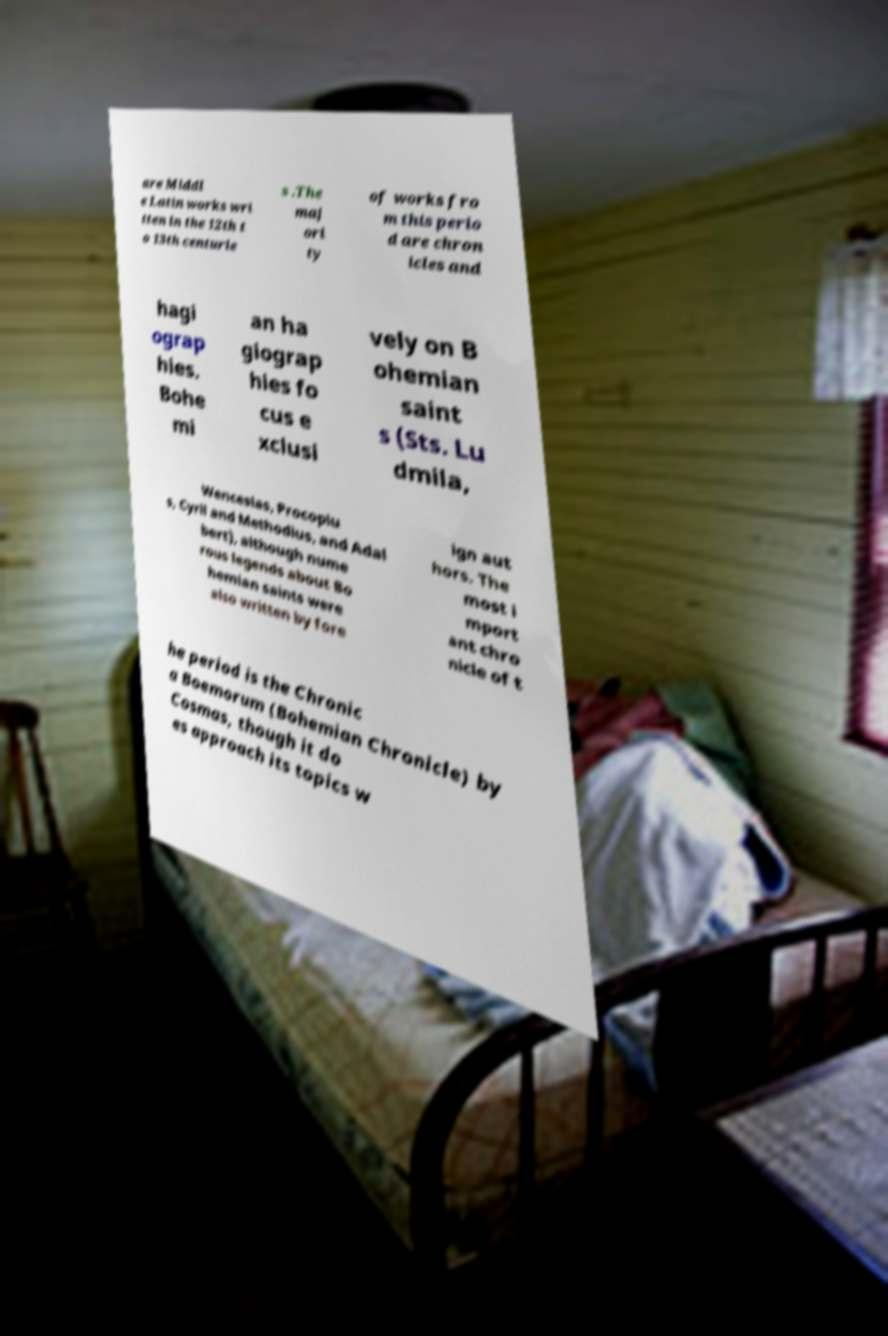I need the written content from this picture converted into text. Can you do that? are Middl e Latin works wri tten in the 12th t o 13th centurie s .The maj ori ty of works fro m this perio d are chron icles and hagi ograp hies. Bohe mi an ha giograp hies fo cus e xclusi vely on B ohemian saint s (Sts. Lu dmila, Wenceslas, Procopiu s, Cyril and Methodius, and Adal bert), although nume rous legends about Bo hemian saints were also written by fore ign aut hors. The most i mport ant chro nicle of t he period is the Chronic a Boemorum (Bohemian Chronicle) by Cosmas, though it do es approach its topics w 